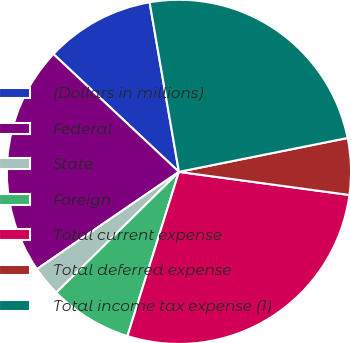Convert chart to OTSL. <chart><loc_0><loc_0><loc_500><loc_500><pie_chart><fcel>(Dollars in millions)<fcel>Federal<fcel>State<fcel>Foreign<fcel>Total current expense<fcel>Total deferred expense<fcel>Total income tax expense (1)<nl><fcel>10.28%<fcel>21.55%<fcel>2.82%<fcel>7.79%<fcel>27.69%<fcel>5.3%<fcel>24.57%<nl></chart> 